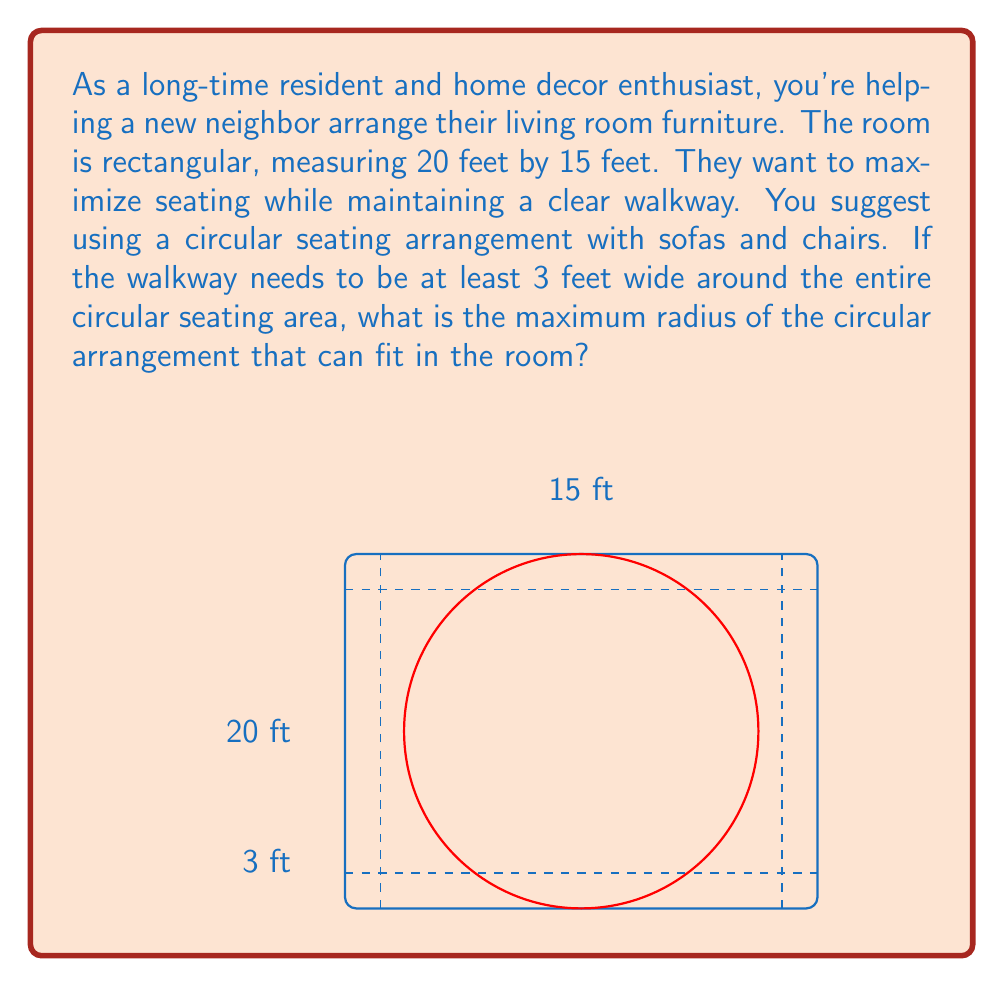Could you help me with this problem? Let's approach this step-by-step:

1) First, we need to consider the constraints. The circular arrangement needs to fit within the room while leaving a 3-foot walkway on all sides.

2) Let's define the radius of the circular arrangement as $r$ feet.

3) The width of the room is 15 feet. With a 3-foot walkway on each side, the diameter of the circle can be at most:
   $$15 - (3 + 3) = 9 \text{ feet}$$

4) Similarly, for the length of 20 feet:
   $$20 - (3 + 3) = 14 \text{ feet}$$

5) The diameter of the circle needs to fit within both these constraints. The smaller of these two is 9 feet, so this is our limiting factor.

6) Since the diameter is 9 feet, the radius would be half of this:
   $$r = \frac{9}{2} = 4.5 \text{ feet}$$

7) We can verify that this circular arrangement with a radius of 4.5 feet would indeed fit within both dimensions of the room:
   - Width: $3 + 4.5 + 4.5 + 3 = 15$ feet (matches room width)
   - Length: $3 + 4.5 + 4.5 + 3 = 15$ feet (less than room length, which is fine)

Therefore, the maximum radius of the circular seating arrangement is 4.5 feet.
Answer: 4.5 feet 